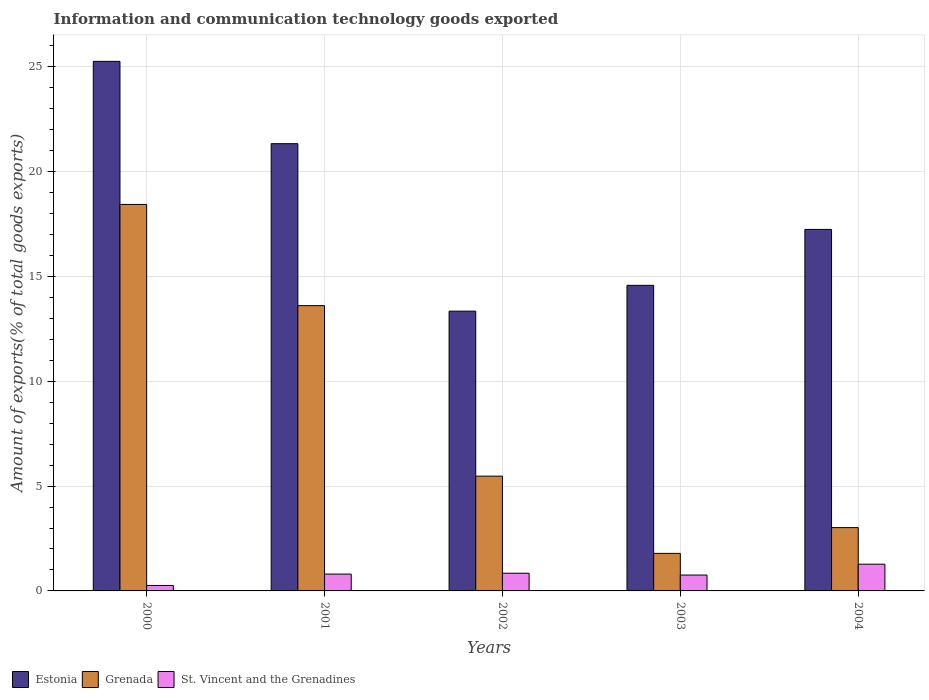How many bars are there on the 1st tick from the left?
Keep it short and to the point. 3. How many bars are there on the 2nd tick from the right?
Provide a succinct answer. 3. What is the label of the 1st group of bars from the left?
Keep it short and to the point. 2000. What is the amount of goods exported in Grenada in 2003?
Your response must be concise. 1.79. Across all years, what is the maximum amount of goods exported in Grenada?
Provide a short and direct response. 18.44. Across all years, what is the minimum amount of goods exported in Estonia?
Keep it short and to the point. 13.34. In which year was the amount of goods exported in St. Vincent and the Grenadines maximum?
Your answer should be very brief. 2004. In which year was the amount of goods exported in Estonia minimum?
Ensure brevity in your answer.  2002. What is the total amount of goods exported in St. Vincent and the Grenadines in the graph?
Make the answer very short. 3.94. What is the difference between the amount of goods exported in St. Vincent and the Grenadines in 2000 and that in 2001?
Offer a very short reply. -0.54. What is the difference between the amount of goods exported in Grenada in 2000 and the amount of goods exported in Estonia in 2002?
Offer a terse response. 5.09. What is the average amount of goods exported in Grenada per year?
Your response must be concise. 8.47. In the year 2002, what is the difference between the amount of goods exported in Grenada and amount of goods exported in St. Vincent and the Grenadines?
Provide a short and direct response. 4.63. In how many years, is the amount of goods exported in Estonia greater than 4 %?
Offer a very short reply. 5. What is the ratio of the amount of goods exported in St. Vincent and the Grenadines in 2002 to that in 2004?
Your answer should be very brief. 0.66. Is the amount of goods exported in Estonia in 2000 less than that in 2003?
Your response must be concise. No. Is the difference between the amount of goods exported in Grenada in 2000 and 2003 greater than the difference between the amount of goods exported in St. Vincent and the Grenadines in 2000 and 2003?
Your response must be concise. Yes. What is the difference between the highest and the second highest amount of goods exported in Estonia?
Keep it short and to the point. 3.93. What is the difference between the highest and the lowest amount of goods exported in Grenada?
Keep it short and to the point. 16.64. Is the sum of the amount of goods exported in St. Vincent and the Grenadines in 2001 and 2003 greater than the maximum amount of goods exported in Grenada across all years?
Give a very brief answer. No. What does the 1st bar from the left in 2004 represents?
Your response must be concise. Estonia. What does the 1st bar from the right in 2004 represents?
Make the answer very short. St. Vincent and the Grenadines. Is it the case that in every year, the sum of the amount of goods exported in Grenada and amount of goods exported in St. Vincent and the Grenadines is greater than the amount of goods exported in Estonia?
Your answer should be very brief. No. How many bars are there?
Give a very brief answer. 15. How many years are there in the graph?
Offer a terse response. 5. What is the difference between two consecutive major ticks on the Y-axis?
Keep it short and to the point. 5. Does the graph contain any zero values?
Provide a short and direct response. No. What is the title of the graph?
Ensure brevity in your answer.  Information and communication technology goods exported. Does "Poland" appear as one of the legend labels in the graph?
Ensure brevity in your answer.  No. What is the label or title of the Y-axis?
Your response must be concise. Amount of exports(% of total goods exports). What is the Amount of exports(% of total goods exports) of Estonia in 2000?
Ensure brevity in your answer.  25.26. What is the Amount of exports(% of total goods exports) of Grenada in 2000?
Offer a very short reply. 18.44. What is the Amount of exports(% of total goods exports) in St. Vincent and the Grenadines in 2000?
Offer a very short reply. 0.26. What is the Amount of exports(% of total goods exports) in Estonia in 2001?
Your answer should be compact. 21.33. What is the Amount of exports(% of total goods exports) in Grenada in 2001?
Your response must be concise. 13.61. What is the Amount of exports(% of total goods exports) of St. Vincent and the Grenadines in 2001?
Make the answer very short. 0.8. What is the Amount of exports(% of total goods exports) in Estonia in 2002?
Your answer should be very brief. 13.34. What is the Amount of exports(% of total goods exports) in Grenada in 2002?
Your answer should be compact. 5.47. What is the Amount of exports(% of total goods exports) in St. Vincent and the Grenadines in 2002?
Your answer should be very brief. 0.84. What is the Amount of exports(% of total goods exports) in Estonia in 2003?
Your answer should be very brief. 14.58. What is the Amount of exports(% of total goods exports) of Grenada in 2003?
Your answer should be compact. 1.79. What is the Amount of exports(% of total goods exports) in St. Vincent and the Grenadines in 2003?
Offer a very short reply. 0.76. What is the Amount of exports(% of total goods exports) in Estonia in 2004?
Your answer should be compact. 17.24. What is the Amount of exports(% of total goods exports) in Grenada in 2004?
Provide a succinct answer. 3.02. What is the Amount of exports(% of total goods exports) of St. Vincent and the Grenadines in 2004?
Your answer should be compact. 1.28. Across all years, what is the maximum Amount of exports(% of total goods exports) in Estonia?
Keep it short and to the point. 25.26. Across all years, what is the maximum Amount of exports(% of total goods exports) in Grenada?
Provide a short and direct response. 18.44. Across all years, what is the maximum Amount of exports(% of total goods exports) in St. Vincent and the Grenadines?
Your response must be concise. 1.28. Across all years, what is the minimum Amount of exports(% of total goods exports) of Estonia?
Your response must be concise. 13.34. Across all years, what is the minimum Amount of exports(% of total goods exports) in Grenada?
Your answer should be very brief. 1.79. Across all years, what is the minimum Amount of exports(% of total goods exports) of St. Vincent and the Grenadines?
Offer a terse response. 0.26. What is the total Amount of exports(% of total goods exports) of Estonia in the graph?
Make the answer very short. 91.76. What is the total Amount of exports(% of total goods exports) of Grenada in the graph?
Offer a terse response. 42.33. What is the total Amount of exports(% of total goods exports) of St. Vincent and the Grenadines in the graph?
Provide a short and direct response. 3.94. What is the difference between the Amount of exports(% of total goods exports) of Estonia in 2000 and that in 2001?
Your answer should be compact. 3.93. What is the difference between the Amount of exports(% of total goods exports) in Grenada in 2000 and that in 2001?
Give a very brief answer. 4.83. What is the difference between the Amount of exports(% of total goods exports) of St. Vincent and the Grenadines in 2000 and that in 2001?
Keep it short and to the point. -0.54. What is the difference between the Amount of exports(% of total goods exports) of Estonia in 2000 and that in 2002?
Your response must be concise. 11.91. What is the difference between the Amount of exports(% of total goods exports) in Grenada in 2000 and that in 2002?
Offer a terse response. 12.96. What is the difference between the Amount of exports(% of total goods exports) in St. Vincent and the Grenadines in 2000 and that in 2002?
Provide a short and direct response. -0.58. What is the difference between the Amount of exports(% of total goods exports) in Estonia in 2000 and that in 2003?
Provide a succinct answer. 10.68. What is the difference between the Amount of exports(% of total goods exports) of Grenada in 2000 and that in 2003?
Ensure brevity in your answer.  16.64. What is the difference between the Amount of exports(% of total goods exports) in St. Vincent and the Grenadines in 2000 and that in 2003?
Your answer should be compact. -0.5. What is the difference between the Amount of exports(% of total goods exports) of Estonia in 2000 and that in 2004?
Your answer should be very brief. 8.02. What is the difference between the Amount of exports(% of total goods exports) of Grenada in 2000 and that in 2004?
Provide a succinct answer. 15.42. What is the difference between the Amount of exports(% of total goods exports) of St. Vincent and the Grenadines in 2000 and that in 2004?
Give a very brief answer. -1.02. What is the difference between the Amount of exports(% of total goods exports) of Estonia in 2001 and that in 2002?
Make the answer very short. 7.99. What is the difference between the Amount of exports(% of total goods exports) of Grenada in 2001 and that in 2002?
Provide a succinct answer. 8.13. What is the difference between the Amount of exports(% of total goods exports) of St. Vincent and the Grenadines in 2001 and that in 2002?
Offer a very short reply. -0.04. What is the difference between the Amount of exports(% of total goods exports) of Estonia in 2001 and that in 2003?
Provide a succinct answer. 6.76. What is the difference between the Amount of exports(% of total goods exports) in Grenada in 2001 and that in 2003?
Provide a short and direct response. 11.82. What is the difference between the Amount of exports(% of total goods exports) in St. Vincent and the Grenadines in 2001 and that in 2003?
Your answer should be compact. 0.05. What is the difference between the Amount of exports(% of total goods exports) of Estonia in 2001 and that in 2004?
Offer a terse response. 4.09. What is the difference between the Amount of exports(% of total goods exports) of Grenada in 2001 and that in 2004?
Your response must be concise. 10.59. What is the difference between the Amount of exports(% of total goods exports) in St. Vincent and the Grenadines in 2001 and that in 2004?
Ensure brevity in your answer.  -0.47. What is the difference between the Amount of exports(% of total goods exports) in Estonia in 2002 and that in 2003?
Your response must be concise. -1.23. What is the difference between the Amount of exports(% of total goods exports) of Grenada in 2002 and that in 2003?
Give a very brief answer. 3.68. What is the difference between the Amount of exports(% of total goods exports) of St. Vincent and the Grenadines in 2002 and that in 2003?
Make the answer very short. 0.09. What is the difference between the Amount of exports(% of total goods exports) in Estonia in 2002 and that in 2004?
Your response must be concise. -3.9. What is the difference between the Amount of exports(% of total goods exports) of Grenada in 2002 and that in 2004?
Keep it short and to the point. 2.45. What is the difference between the Amount of exports(% of total goods exports) of St. Vincent and the Grenadines in 2002 and that in 2004?
Provide a succinct answer. -0.43. What is the difference between the Amount of exports(% of total goods exports) in Estonia in 2003 and that in 2004?
Provide a short and direct response. -2.67. What is the difference between the Amount of exports(% of total goods exports) of Grenada in 2003 and that in 2004?
Give a very brief answer. -1.23. What is the difference between the Amount of exports(% of total goods exports) of St. Vincent and the Grenadines in 2003 and that in 2004?
Provide a succinct answer. -0.52. What is the difference between the Amount of exports(% of total goods exports) of Estonia in 2000 and the Amount of exports(% of total goods exports) of Grenada in 2001?
Provide a short and direct response. 11.65. What is the difference between the Amount of exports(% of total goods exports) in Estonia in 2000 and the Amount of exports(% of total goods exports) in St. Vincent and the Grenadines in 2001?
Provide a succinct answer. 24.46. What is the difference between the Amount of exports(% of total goods exports) of Grenada in 2000 and the Amount of exports(% of total goods exports) of St. Vincent and the Grenadines in 2001?
Offer a very short reply. 17.63. What is the difference between the Amount of exports(% of total goods exports) in Estonia in 2000 and the Amount of exports(% of total goods exports) in Grenada in 2002?
Your answer should be compact. 19.78. What is the difference between the Amount of exports(% of total goods exports) in Estonia in 2000 and the Amount of exports(% of total goods exports) in St. Vincent and the Grenadines in 2002?
Offer a terse response. 24.42. What is the difference between the Amount of exports(% of total goods exports) of Grenada in 2000 and the Amount of exports(% of total goods exports) of St. Vincent and the Grenadines in 2002?
Your answer should be compact. 17.59. What is the difference between the Amount of exports(% of total goods exports) of Estonia in 2000 and the Amount of exports(% of total goods exports) of Grenada in 2003?
Make the answer very short. 23.47. What is the difference between the Amount of exports(% of total goods exports) in Estonia in 2000 and the Amount of exports(% of total goods exports) in St. Vincent and the Grenadines in 2003?
Your answer should be compact. 24.5. What is the difference between the Amount of exports(% of total goods exports) in Grenada in 2000 and the Amount of exports(% of total goods exports) in St. Vincent and the Grenadines in 2003?
Ensure brevity in your answer.  17.68. What is the difference between the Amount of exports(% of total goods exports) in Estonia in 2000 and the Amount of exports(% of total goods exports) in Grenada in 2004?
Give a very brief answer. 22.24. What is the difference between the Amount of exports(% of total goods exports) of Estonia in 2000 and the Amount of exports(% of total goods exports) of St. Vincent and the Grenadines in 2004?
Offer a terse response. 23.98. What is the difference between the Amount of exports(% of total goods exports) of Grenada in 2000 and the Amount of exports(% of total goods exports) of St. Vincent and the Grenadines in 2004?
Provide a short and direct response. 17.16. What is the difference between the Amount of exports(% of total goods exports) of Estonia in 2001 and the Amount of exports(% of total goods exports) of Grenada in 2002?
Make the answer very short. 15.86. What is the difference between the Amount of exports(% of total goods exports) of Estonia in 2001 and the Amount of exports(% of total goods exports) of St. Vincent and the Grenadines in 2002?
Your response must be concise. 20.49. What is the difference between the Amount of exports(% of total goods exports) of Grenada in 2001 and the Amount of exports(% of total goods exports) of St. Vincent and the Grenadines in 2002?
Offer a very short reply. 12.76. What is the difference between the Amount of exports(% of total goods exports) of Estonia in 2001 and the Amount of exports(% of total goods exports) of Grenada in 2003?
Provide a succinct answer. 19.54. What is the difference between the Amount of exports(% of total goods exports) of Estonia in 2001 and the Amount of exports(% of total goods exports) of St. Vincent and the Grenadines in 2003?
Offer a very short reply. 20.58. What is the difference between the Amount of exports(% of total goods exports) in Grenada in 2001 and the Amount of exports(% of total goods exports) in St. Vincent and the Grenadines in 2003?
Give a very brief answer. 12.85. What is the difference between the Amount of exports(% of total goods exports) of Estonia in 2001 and the Amount of exports(% of total goods exports) of Grenada in 2004?
Provide a short and direct response. 18.31. What is the difference between the Amount of exports(% of total goods exports) of Estonia in 2001 and the Amount of exports(% of total goods exports) of St. Vincent and the Grenadines in 2004?
Your answer should be very brief. 20.06. What is the difference between the Amount of exports(% of total goods exports) of Grenada in 2001 and the Amount of exports(% of total goods exports) of St. Vincent and the Grenadines in 2004?
Ensure brevity in your answer.  12.33. What is the difference between the Amount of exports(% of total goods exports) in Estonia in 2002 and the Amount of exports(% of total goods exports) in Grenada in 2003?
Make the answer very short. 11.55. What is the difference between the Amount of exports(% of total goods exports) of Estonia in 2002 and the Amount of exports(% of total goods exports) of St. Vincent and the Grenadines in 2003?
Offer a very short reply. 12.59. What is the difference between the Amount of exports(% of total goods exports) of Grenada in 2002 and the Amount of exports(% of total goods exports) of St. Vincent and the Grenadines in 2003?
Your response must be concise. 4.72. What is the difference between the Amount of exports(% of total goods exports) in Estonia in 2002 and the Amount of exports(% of total goods exports) in Grenada in 2004?
Make the answer very short. 10.32. What is the difference between the Amount of exports(% of total goods exports) of Estonia in 2002 and the Amount of exports(% of total goods exports) of St. Vincent and the Grenadines in 2004?
Provide a short and direct response. 12.07. What is the difference between the Amount of exports(% of total goods exports) in Grenada in 2002 and the Amount of exports(% of total goods exports) in St. Vincent and the Grenadines in 2004?
Your answer should be very brief. 4.2. What is the difference between the Amount of exports(% of total goods exports) of Estonia in 2003 and the Amount of exports(% of total goods exports) of Grenada in 2004?
Make the answer very short. 11.56. What is the difference between the Amount of exports(% of total goods exports) in Estonia in 2003 and the Amount of exports(% of total goods exports) in St. Vincent and the Grenadines in 2004?
Offer a terse response. 13.3. What is the difference between the Amount of exports(% of total goods exports) in Grenada in 2003 and the Amount of exports(% of total goods exports) in St. Vincent and the Grenadines in 2004?
Offer a very short reply. 0.52. What is the average Amount of exports(% of total goods exports) in Estonia per year?
Keep it short and to the point. 18.35. What is the average Amount of exports(% of total goods exports) of Grenada per year?
Provide a short and direct response. 8.47. What is the average Amount of exports(% of total goods exports) of St. Vincent and the Grenadines per year?
Your response must be concise. 0.79. In the year 2000, what is the difference between the Amount of exports(% of total goods exports) in Estonia and Amount of exports(% of total goods exports) in Grenada?
Ensure brevity in your answer.  6.82. In the year 2000, what is the difference between the Amount of exports(% of total goods exports) in Estonia and Amount of exports(% of total goods exports) in St. Vincent and the Grenadines?
Provide a short and direct response. 25. In the year 2000, what is the difference between the Amount of exports(% of total goods exports) in Grenada and Amount of exports(% of total goods exports) in St. Vincent and the Grenadines?
Provide a succinct answer. 18.18. In the year 2001, what is the difference between the Amount of exports(% of total goods exports) of Estonia and Amount of exports(% of total goods exports) of Grenada?
Your answer should be very brief. 7.72. In the year 2001, what is the difference between the Amount of exports(% of total goods exports) of Estonia and Amount of exports(% of total goods exports) of St. Vincent and the Grenadines?
Provide a short and direct response. 20.53. In the year 2001, what is the difference between the Amount of exports(% of total goods exports) of Grenada and Amount of exports(% of total goods exports) of St. Vincent and the Grenadines?
Make the answer very short. 12.8. In the year 2002, what is the difference between the Amount of exports(% of total goods exports) of Estonia and Amount of exports(% of total goods exports) of Grenada?
Give a very brief answer. 7.87. In the year 2002, what is the difference between the Amount of exports(% of total goods exports) of Estonia and Amount of exports(% of total goods exports) of St. Vincent and the Grenadines?
Provide a short and direct response. 12.5. In the year 2002, what is the difference between the Amount of exports(% of total goods exports) of Grenada and Amount of exports(% of total goods exports) of St. Vincent and the Grenadines?
Ensure brevity in your answer.  4.63. In the year 2003, what is the difference between the Amount of exports(% of total goods exports) of Estonia and Amount of exports(% of total goods exports) of Grenada?
Your response must be concise. 12.79. In the year 2003, what is the difference between the Amount of exports(% of total goods exports) in Estonia and Amount of exports(% of total goods exports) in St. Vincent and the Grenadines?
Your answer should be compact. 13.82. In the year 2003, what is the difference between the Amount of exports(% of total goods exports) in Grenada and Amount of exports(% of total goods exports) in St. Vincent and the Grenadines?
Make the answer very short. 1.03. In the year 2004, what is the difference between the Amount of exports(% of total goods exports) in Estonia and Amount of exports(% of total goods exports) in Grenada?
Your response must be concise. 14.22. In the year 2004, what is the difference between the Amount of exports(% of total goods exports) in Estonia and Amount of exports(% of total goods exports) in St. Vincent and the Grenadines?
Give a very brief answer. 15.97. In the year 2004, what is the difference between the Amount of exports(% of total goods exports) of Grenada and Amount of exports(% of total goods exports) of St. Vincent and the Grenadines?
Give a very brief answer. 1.74. What is the ratio of the Amount of exports(% of total goods exports) in Estonia in 2000 to that in 2001?
Offer a terse response. 1.18. What is the ratio of the Amount of exports(% of total goods exports) in Grenada in 2000 to that in 2001?
Keep it short and to the point. 1.35. What is the ratio of the Amount of exports(% of total goods exports) of St. Vincent and the Grenadines in 2000 to that in 2001?
Offer a very short reply. 0.32. What is the ratio of the Amount of exports(% of total goods exports) in Estonia in 2000 to that in 2002?
Your response must be concise. 1.89. What is the ratio of the Amount of exports(% of total goods exports) of Grenada in 2000 to that in 2002?
Ensure brevity in your answer.  3.37. What is the ratio of the Amount of exports(% of total goods exports) in St. Vincent and the Grenadines in 2000 to that in 2002?
Your response must be concise. 0.31. What is the ratio of the Amount of exports(% of total goods exports) in Estonia in 2000 to that in 2003?
Your response must be concise. 1.73. What is the ratio of the Amount of exports(% of total goods exports) in Grenada in 2000 to that in 2003?
Your answer should be very brief. 10.3. What is the ratio of the Amount of exports(% of total goods exports) of St. Vincent and the Grenadines in 2000 to that in 2003?
Your response must be concise. 0.34. What is the ratio of the Amount of exports(% of total goods exports) in Estonia in 2000 to that in 2004?
Provide a short and direct response. 1.46. What is the ratio of the Amount of exports(% of total goods exports) of Grenada in 2000 to that in 2004?
Provide a succinct answer. 6.1. What is the ratio of the Amount of exports(% of total goods exports) in St. Vincent and the Grenadines in 2000 to that in 2004?
Give a very brief answer. 0.2. What is the ratio of the Amount of exports(% of total goods exports) of Estonia in 2001 to that in 2002?
Provide a succinct answer. 1.6. What is the ratio of the Amount of exports(% of total goods exports) of Grenada in 2001 to that in 2002?
Ensure brevity in your answer.  2.49. What is the ratio of the Amount of exports(% of total goods exports) of St. Vincent and the Grenadines in 2001 to that in 2002?
Ensure brevity in your answer.  0.95. What is the ratio of the Amount of exports(% of total goods exports) of Estonia in 2001 to that in 2003?
Give a very brief answer. 1.46. What is the ratio of the Amount of exports(% of total goods exports) in Grenada in 2001 to that in 2003?
Offer a very short reply. 7.6. What is the ratio of the Amount of exports(% of total goods exports) of St. Vincent and the Grenadines in 2001 to that in 2003?
Offer a very short reply. 1.06. What is the ratio of the Amount of exports(% of total goods exports) of Estonia in 2001 to that in 2004?
Keep it short and to the point. 1.24. What is the ratio of the Amount of exports(% of total goods exports) in Grenada in 2001 to that in 2004?
Make the answer very short. 4.51. What is the ratio of the Amount of exports(% of total goods exports) of St. Vincent and the Grenadines in 2001 to that in 2004?
Provide a succinct answer. 0.63. What is the ratio of the Amount of exports(% of total goods exports) in Estonia in 2002 to that in 2003?
Give a very brief answer. 0.92. What is the ratio of the Amount of exports(% of total goods exports) of Grenada in 2002 to that in 2003?
Keep it short and to the point. 3.06. What is the ratio of the Amount of exports(% of total goods exports) of St. Vincent and the Grenadines in 2002 to that in 2003?
Keep it short and to the point. 1.11. What is the ratio of the Amount of exports(% of total goods exports) of Estonia in 2002 to that in 2004?
Your answer should be very brief. 0.77. What is the ratio of the Amount of exports(% of total goods exports) in Grenada in 2002 to that in 2004?
Give a very brief answer. 1.81. What is the ratio of the Amount of exports(% of total goods exports) in St. Vincent and the Grenadines in 2002 to that in 2004?
Your answer should be compact. 0.66. What is the ratio of the Amount of exports(% of total goods exports) of Estonia in 2003 to that in 2004?
Your answer should be very brief. 0.85. What is the ratio of the Amount of exports(% of total goods exports) of Grenada in 2003 to that in 2004?
Your response must be concise. 0.59. What is the ratio of the Amount of exports(% of total goods exports) in St. Vincent and the Grenadines in 2003 to that in 2004?
Provide a short and direct response. 0.59. What is the difference between the highest and the second highest Amount of exports(% of total goods exports) of Estonia?
Your answer should be compact. 3.93. What is the difference between the highest and the second highest Amount of exports(% of total goods exports) in Grenada?
Offer a very short reply. 4.83. What is the difference between the highest and the second highest Amount of exports(% of total goods exports) of St. Vincent and the Grenadines?
Offer a terse response. 0.43. What is the difference between the highest and the lowest Amount of exports(% of total goods exports) of Estonia?
Your answer should be compact. 11.91. What is the difference between the highest and the lowest Amount of exports(% of total goods exports) in Grenada?
Offer a very short reply. 16.64. What is the difference between the highest and the lowest Amount of exports(% of total goods exports) in St. Vincent and the Grenadines?
Ensure brevity in your answer.  1.02. 